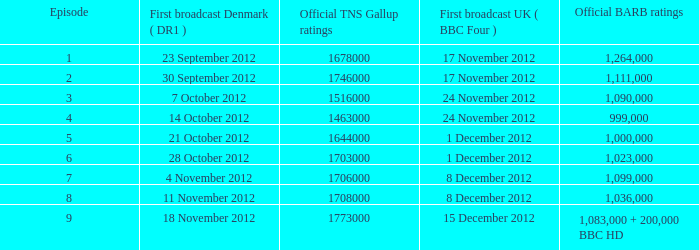What is the barb score for episode 6? 1023000.0. 